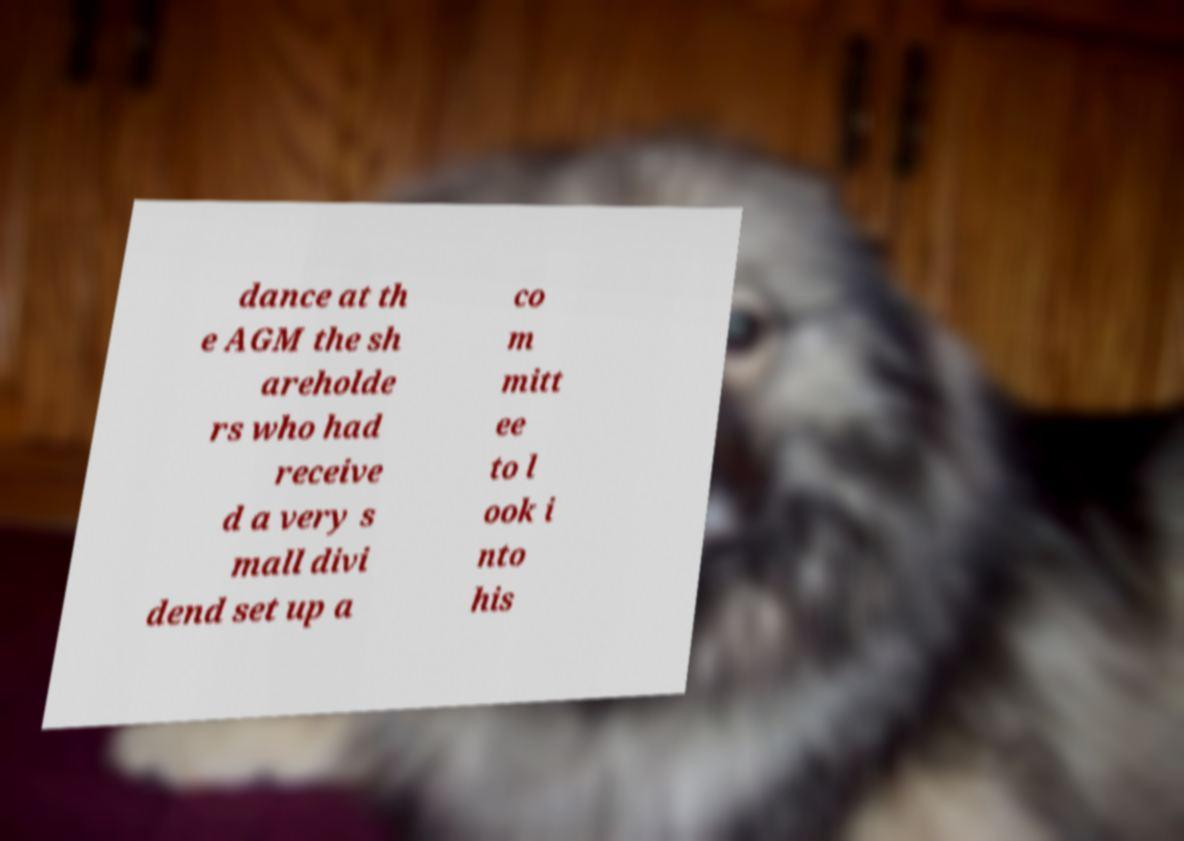For documentation purposes, I need the text within this image transcribed. Could you provide that? dance at th e AGM the sh areholde rs who had receive d a very s mall divi dend set up a co m mitt ee to l ook i nto his 